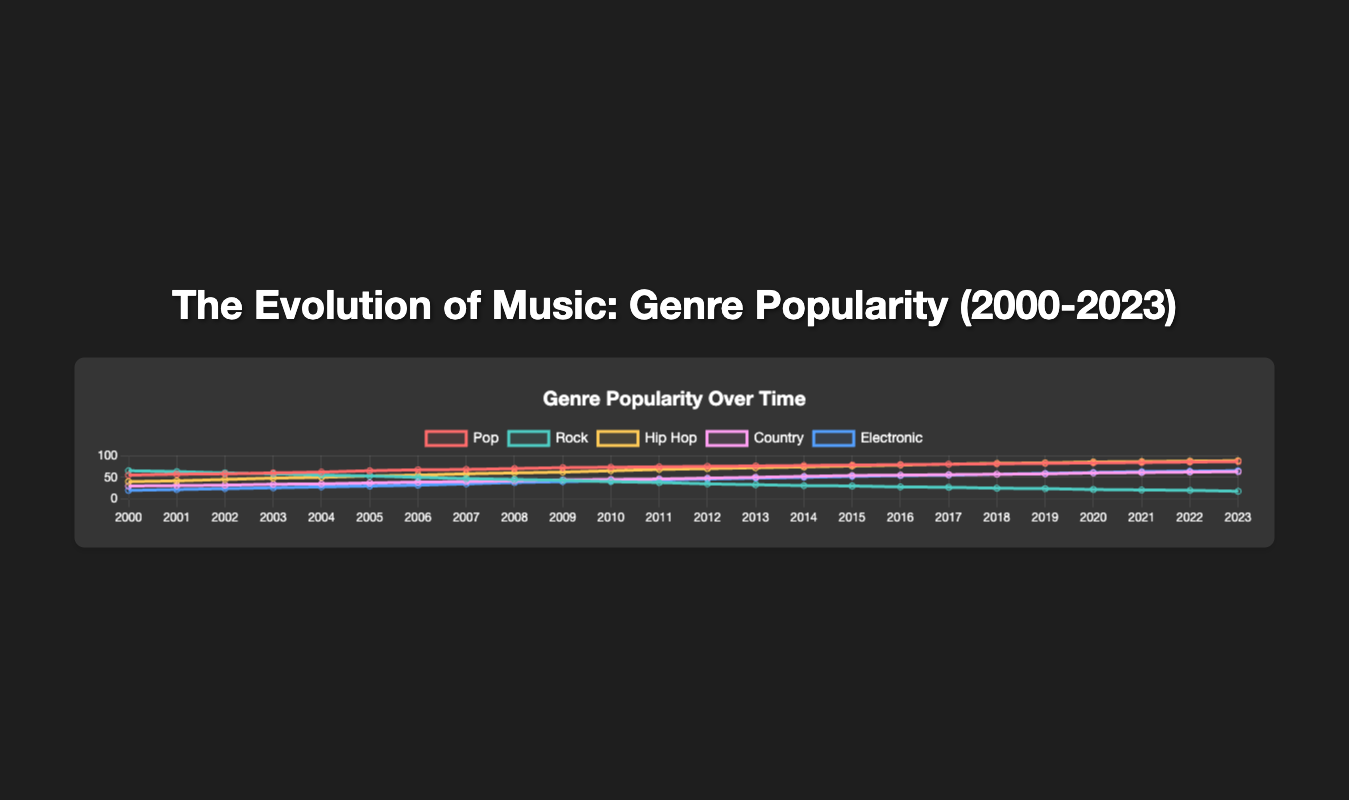What trend do you see for the popularity of Hip Hop from 2000 to 2023? Hip Hop popularity shows a consistent and significant increase from 40 in 2000 to 88 in 2023.
Answer: Increasing Which music genre had the highest popularity in 2000 and which one had the highest popularity in 2023? In 2000, Rock had the highest popularity at 65. In 2023, Hip Hop had the highest popularity at 88.
Answer: Rock in 2000, Hip Hop in 2023 What is the difference in popularity between Pop and Rock in 2023? In 2023, Pop had a popularity of 86 and Rock had a popularity of 18. The difference is 86 - 18 = 68.
Answer: 68 Between 2000 and 2023, which year did Pop surpass Rock in popularity? By examining the trends, Pop surpassed Rock in 2004, with Pop at 62 and Rock at 55.
Answer: 2004 Over the years, which genre shows the most consistent increase in popularity? Hip Hop shows the most consistent increase in popularity, increasing every year from 40 in 2000 to 88 in 2023.
Answer: Hip Hop What is the average popularity of Electronic music from 2000 to 2023? To find the average popularity, sum all the Electronic values and divide by the number of years (24). Sum = 20 + 22 + 24 + 26 + 28 + 30 + 32 + 35 + 38 + 40 + 42 + 44 + 46 + 48 + 50 + 52 + 54 + 55 + 57 + 59 + 61 + 63 + 64 + 65 = 1090. The average is 1090/24 ≈ 45.42.
Answer: 45.42 How much did Country music popularity grow from 2000 to 2023? The popularity of Country music in 2000 was 30, and in 2023 it was 63. The growth is 63 - 30 = 33.
Answer: 33 In which year did Electronic music reach a popularity of 50? Electronic music reached a popularity of 50 in 2014.
Answer: 2014 Which genre saw a decline in popularity from 2000 to 2023? Rock saw a decline in popularity, going from 65 in 2000 to 18 in 2023.
Answer: Rock Comparing 2010 and 2020, which genre showed the most significant increase in popularity? Comparing 2010 and 2020, Electronic music showed the most significant increase from 42 in 2010 to 61 in 2020, an increase of 19.
Answer: Electronic 